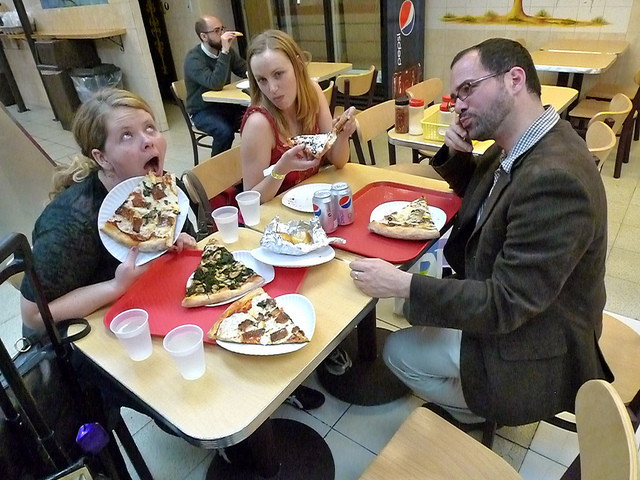What are the people doing in this image? The individuals appear to be in a casual dining setting, seemingly engaged in eating large slices of pizza with varying toppings, expressing enjoyment and surprise. 